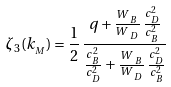Convert formula to latex. <formula><loc_0><loc_0><loc_500><loc_500>\zeta _ { 3 } ( k _ { _ { M } } ) = \frac { 1 } { 2 } \, \frac { q + \frac { W \, { _ { _ { B } } } } { W \, { _ { _ { D } } } } \, \frac { c _ { _ { D } } ^ { 2 } } { c _ { _ { B } } ^ { 2 } } } { \frac { c _ { _ { B } } ^ { 2 } } { c _ { _ { D } } ^ { 2 } } + \frac { W \, { _ { _ { B } } } } { W \, { _ { _ { D } } } } \, \frac { c _ { _ { D } } ^ { 2 } } { c _ { _ { B } } ^ { 2 } } }</formula> 